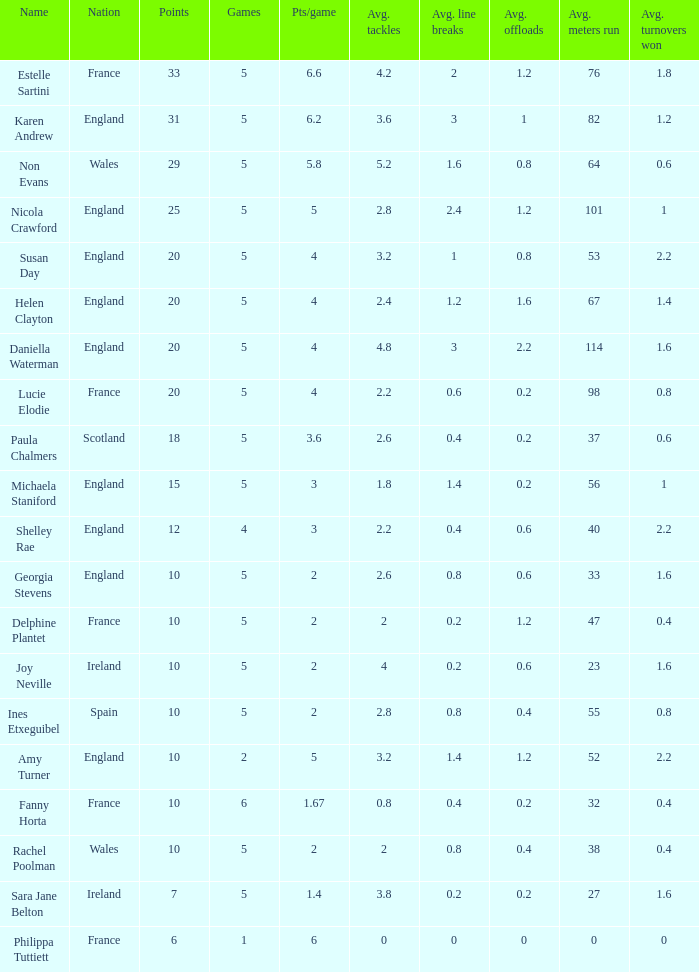Can you tell me the lowest Games that has the Pts/game larger than 1.4 and the Points of 20, and the Name of susan day? 5.0. 